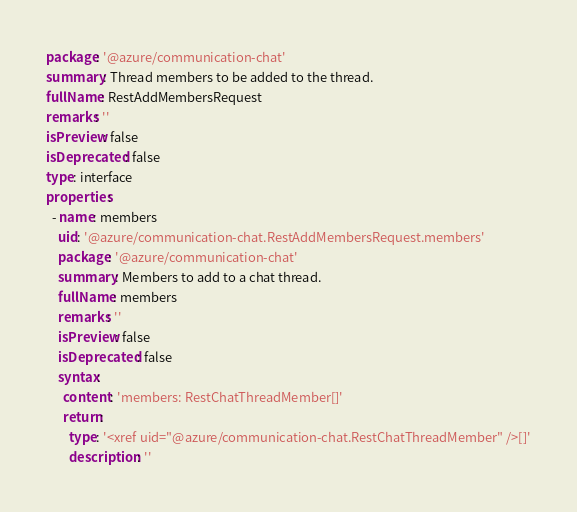<code> <loc_0><loc_0><loc_500><loc_500><_YAML_>package: '@azure/communication-chat'
summary: Thread members to be added to the thread.
fullName: RestAddMembersRequest
remarks: ''
isPreview: false
isDeprecated: false
type: interface
properties:
  - name: members
    uid: '@azure/communication-chat.RestAddMembersRequest.members'
    package: '@azure/communication-chat'
    summary: Members to add to a chat thread.
    fullName: members
    remarks: ''
    isPreview: false
    isDeprecated: false
    syntax:
      content: 'members: RestChatThreadMember[]'
      return:
        type: '<xref uid="@azure/communication-chat.RestChatThreadMember" />[]'
        description: ''
</code> 